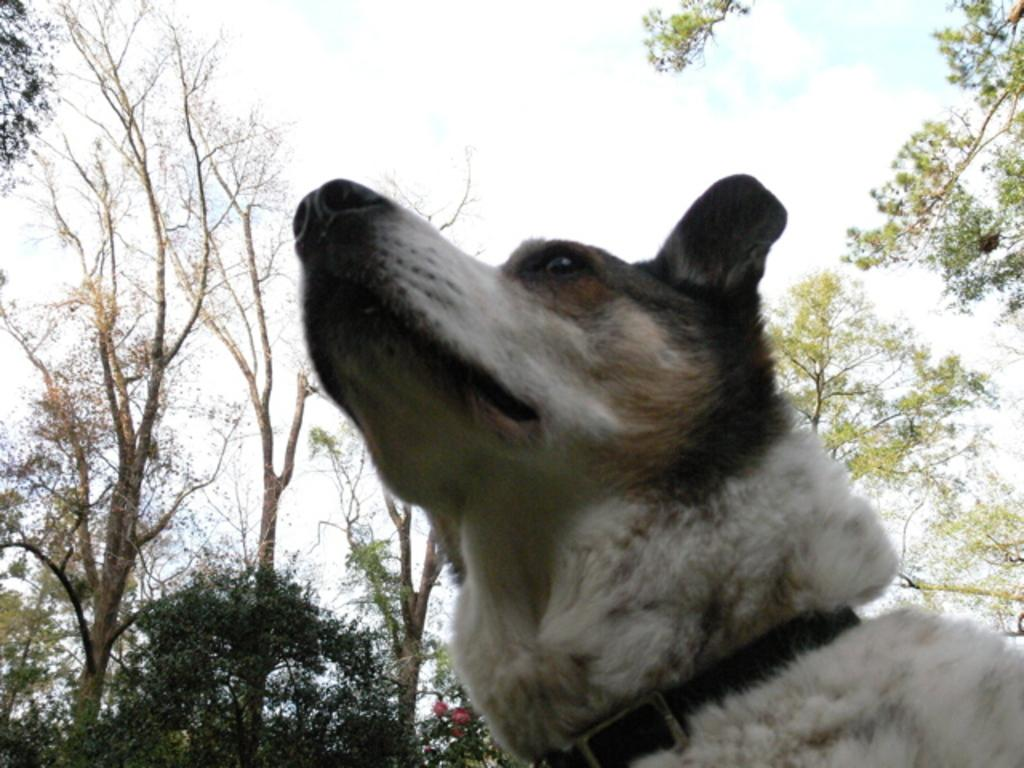What type of animal is present in the image? There is a dog in the image. What other living organisms can be seen in the image? There are plants and trees in the image. What part of the natural environment is visible in the image? The sky is visible in the image. What can be observed in the sky? There are clouds in the sky. What type of rice is being cooked in the image? There is no rice present in the image. How many legs does the dog have in the image? The image does not show the dog's legs, but dogs typically have four legs. 